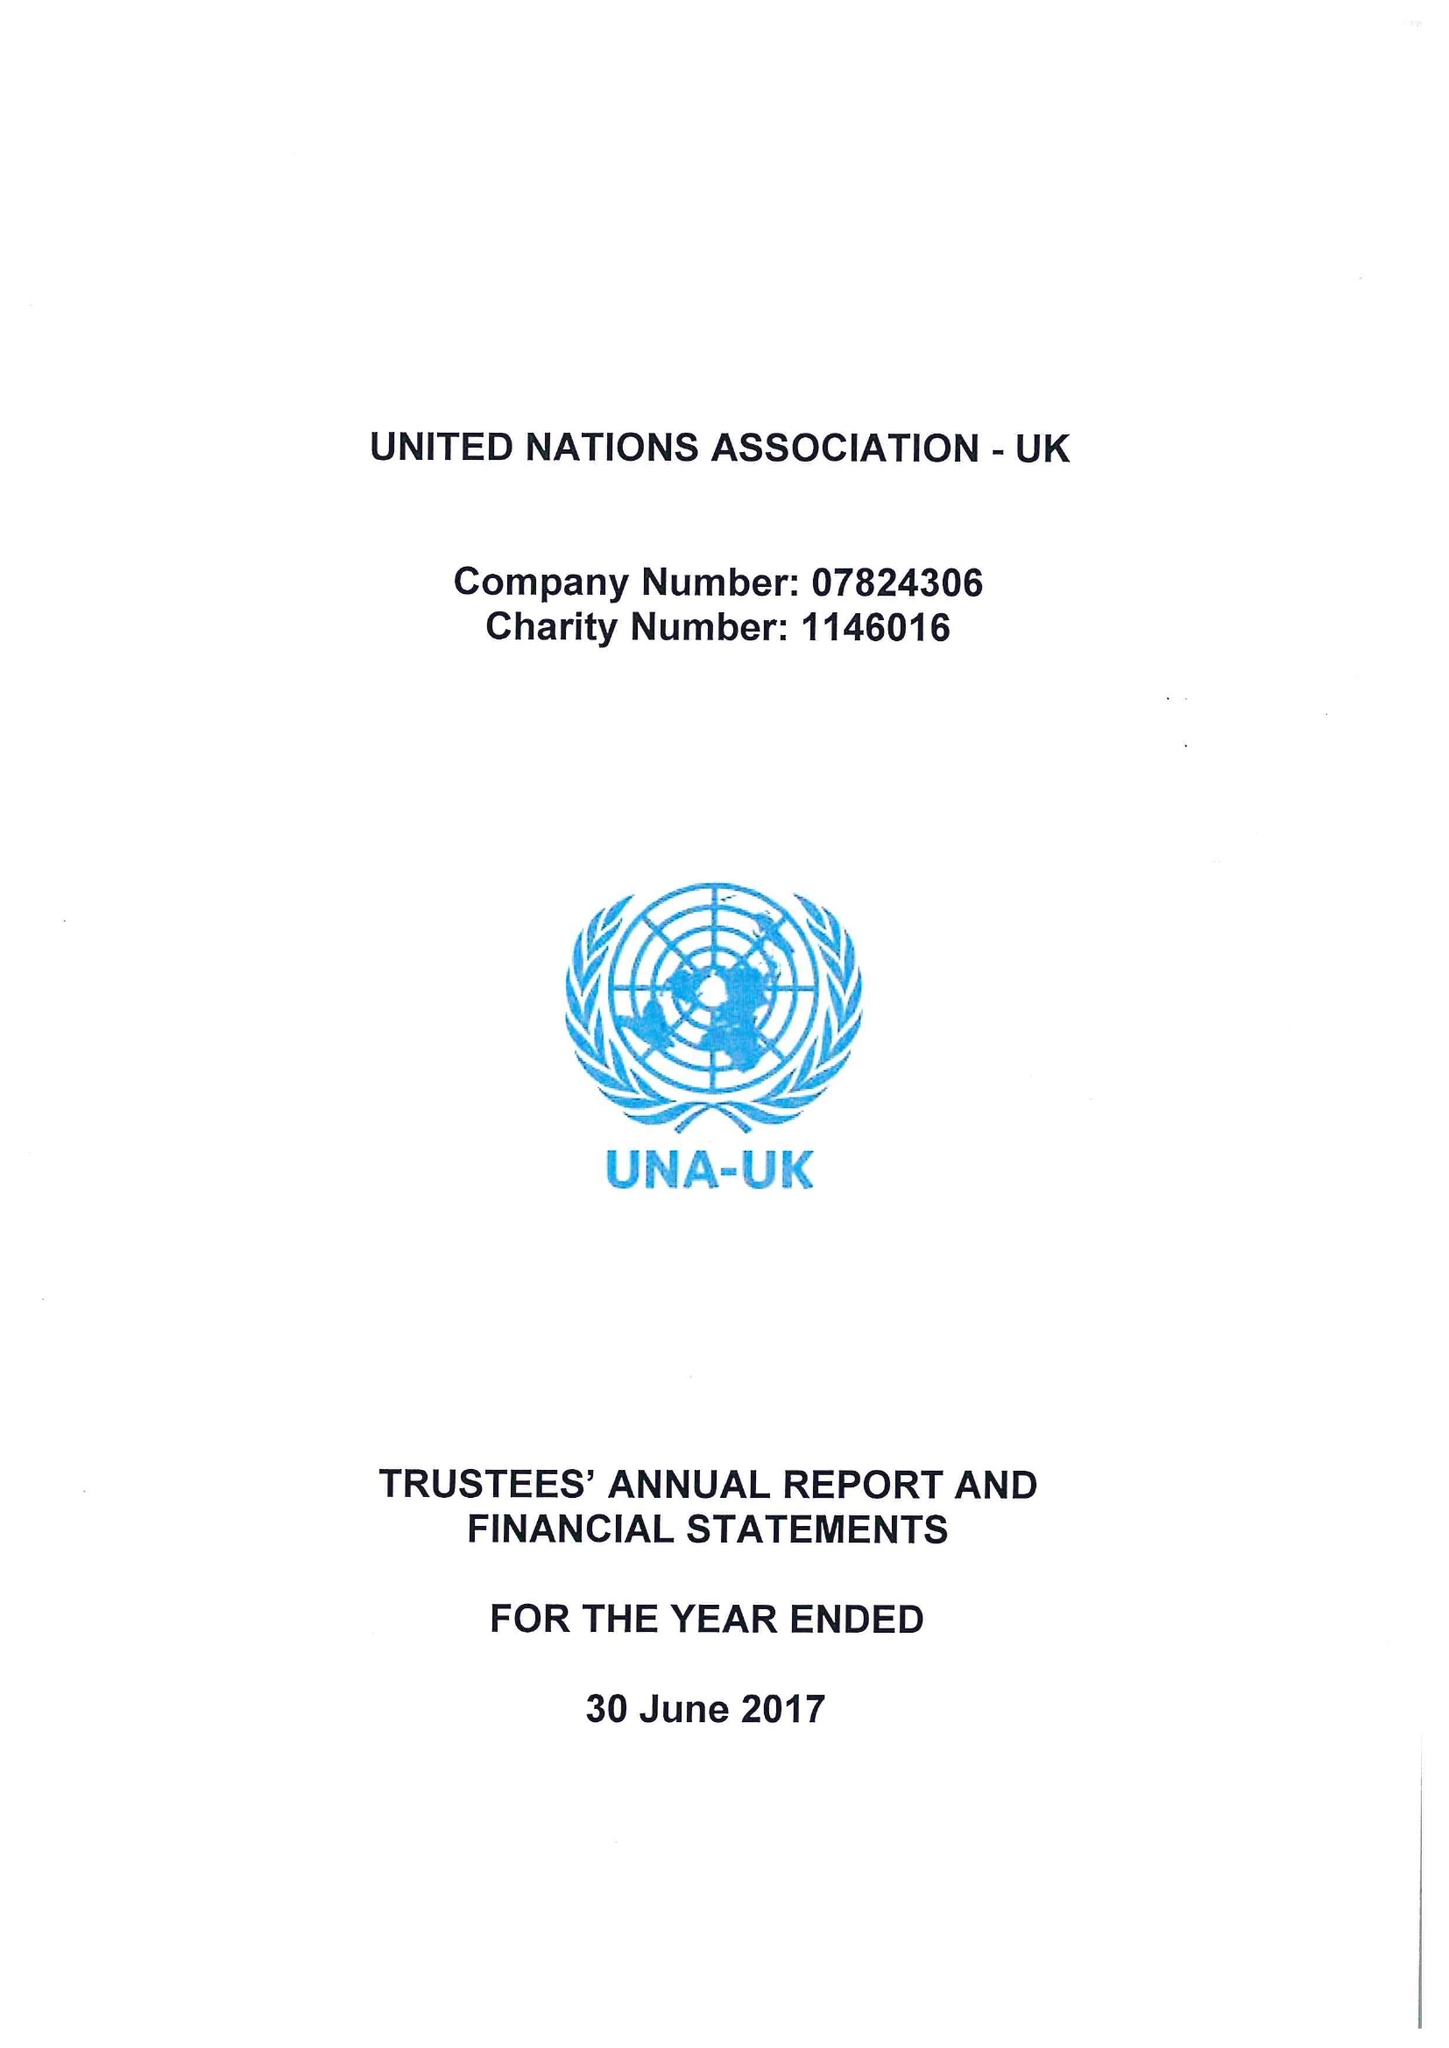What is the value for the income_annually_in_british_pounds?
Answer the question using a single word or phrase. 328811.00 